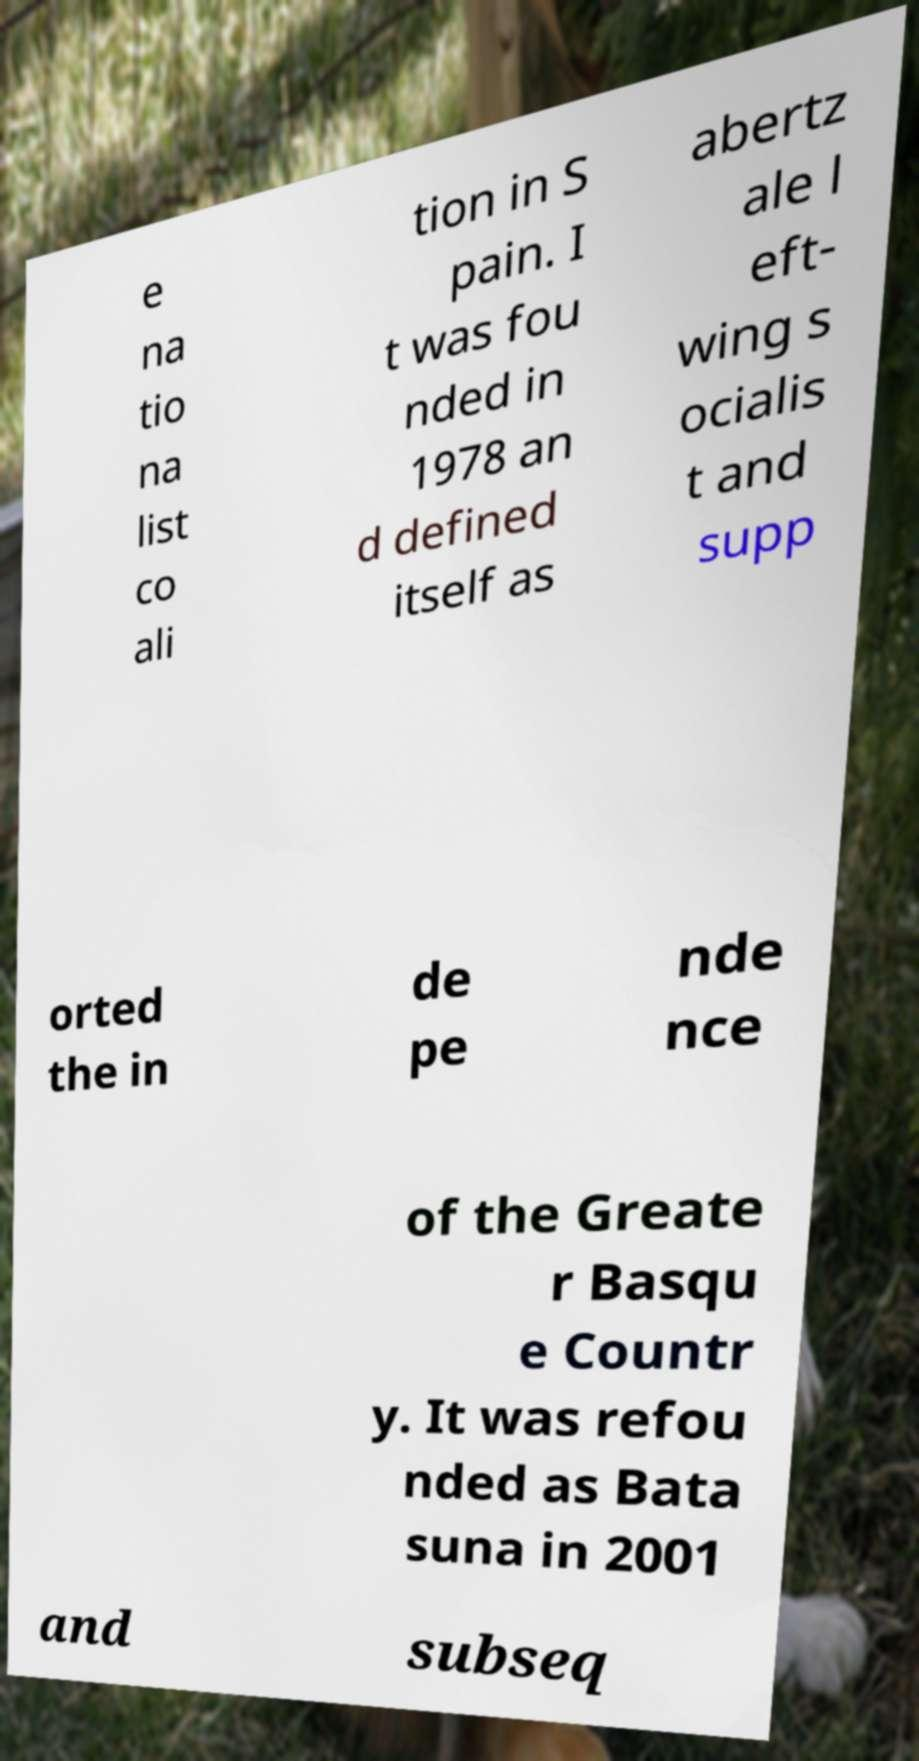I need the written content from this picture converted into text. Can you do that? e na tio na list co ali tion in S pain. I t was fou nded in 1978 an d defined itself as abertz ale l eft- wing s ocialis t and supp orted the in de pe nde nce of the Greate r Basqu e Countr y. It was refou nded as Bata suna in 2001 and subseq 